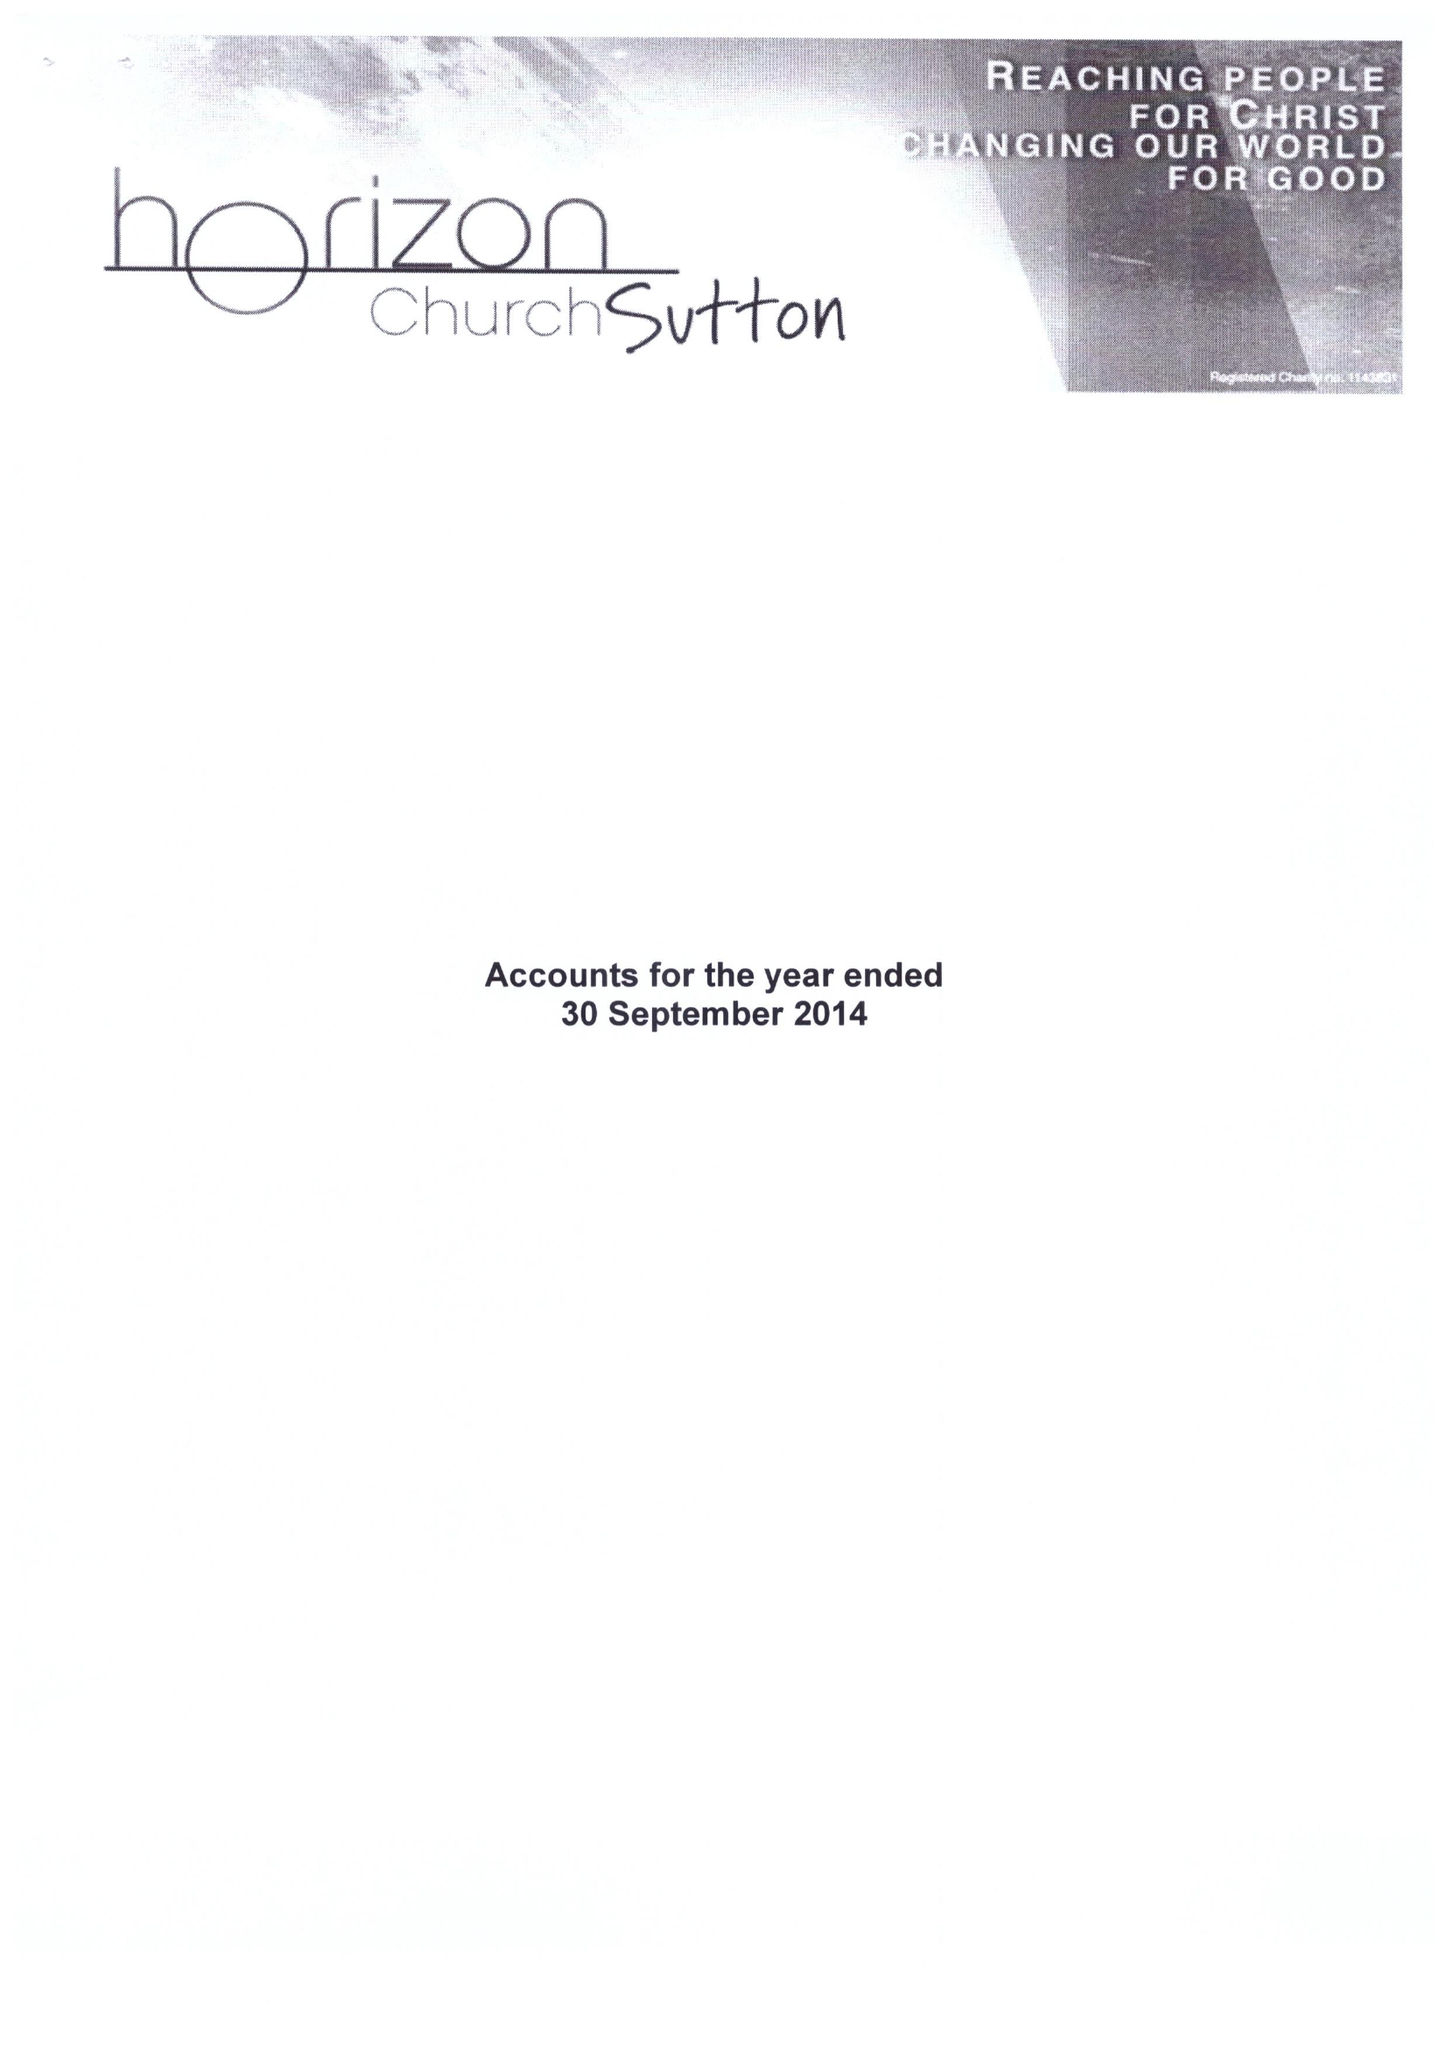What is the value for the address__post_town?
Answer the question using a single word or phrase. CARSHALTON 